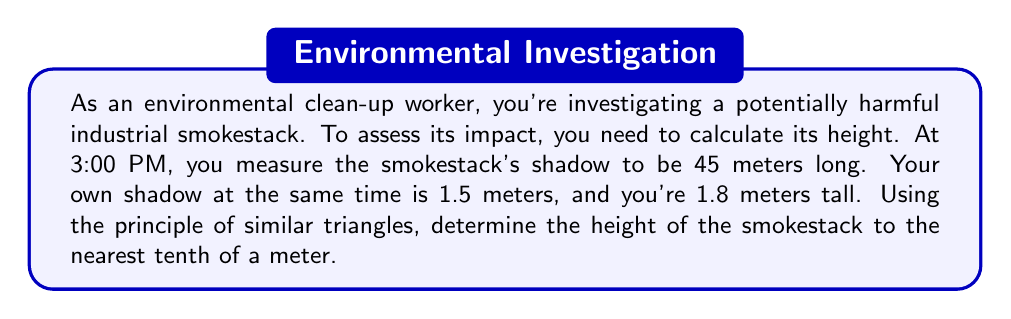Give your solution to this math problem. Let's approach this step-by-step using the principle of similar triangles:

1) We can set up two similar triangles:
   a) Triangle formed by you and your shadow
   b) Triangle formed by the smokestack and its shadow

2) Let's define variables:
   $h$ = height of the smokestack (unknown)
   $s$ = length of smokestack's shadow = 45 m
   $H$ = your height = 1.8 m
   $S$ = length of your shadow = 1.5 m

3) The ratios of corresponding sides in similar triangles are equal:

   $$\frac{h}{s} = \frac{H}{S}$$

4) Substituting known values:

   $$\frac{h}{45} = \frac{1.8}{1.5}$$

5) Cross multiply:

   $$1.5h = 45 \times 1.8$$

6) Simplify the right side:

   $$1.5h = 81$$

7) Divide both sides by 1.5:

   $$h = \frac{81}{1.5} = 54$$

8) Therefore, the height of the smokestack is 54 meters.

[asy]
unitsize(2mm);
draw((0,0)--(30,0)--(30,36)--(0,0),black);
draw((0,0)--(35,0)--(35,1.8)--(0,0),black);
label("45 m", (15,-1), S);
label("1.5 m", (17.5,-1), S);
label("h", (31,18), E);
label("1.8 m", (35.5,0.9), E);
[/asy]
Answer: 54.0 m 